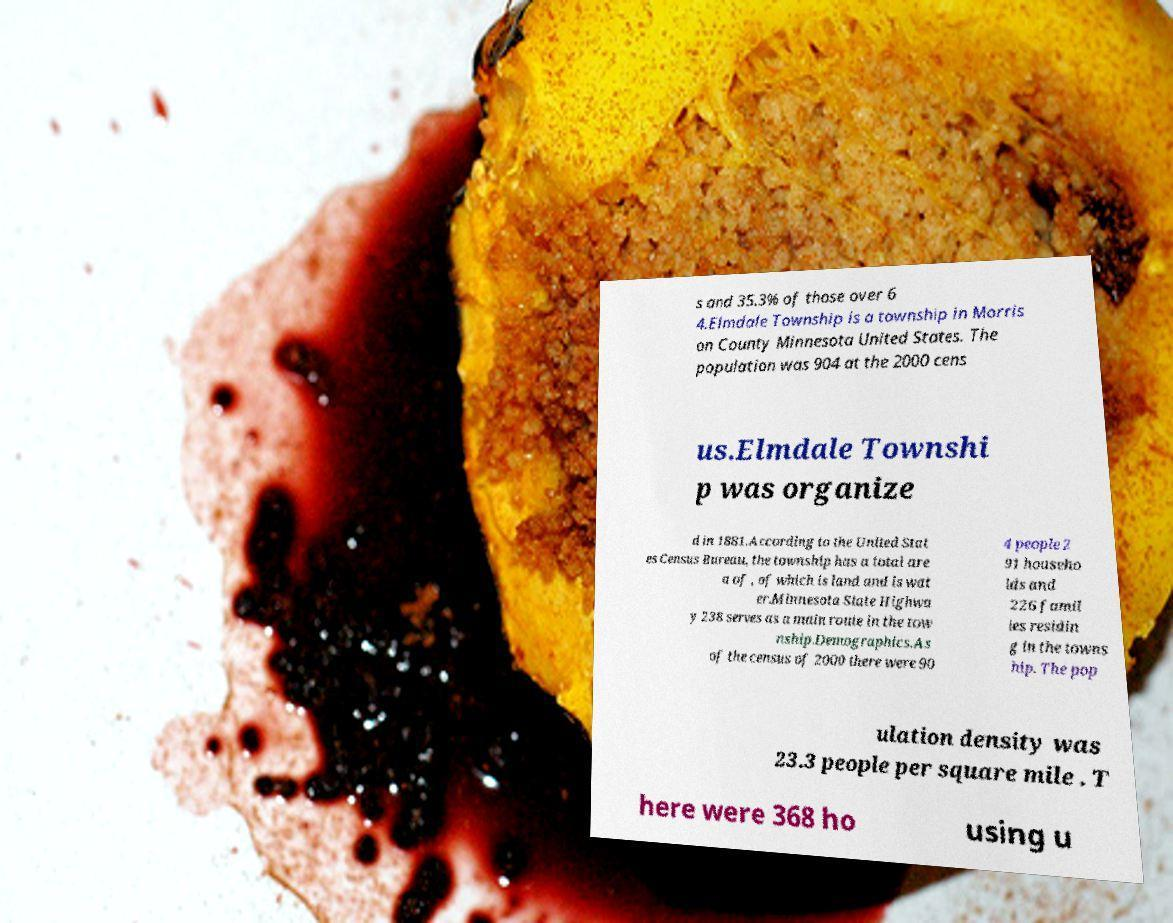Please identify and transcribe the text found in this image. s and 35.3% of those over 6 4.Elmdale Township is a township in Morris on County Minnesota United States. The population was 904 at the 2000 cens us.Elmdale Townshi p was organize d in 1881.According to the United Stat es Census Bureau, the township has a total are a of , of which is land and is wat er.Minnesota State Highwa y 238 serves as a main route in the tow nship.Demographics.As of the census of 2000 there were 90 4 people 2 91 househo lds and 226 famil ies residin g in the towns hip. The pop ulation density was 23.3 people per square mile . T here were 368 ho using u 